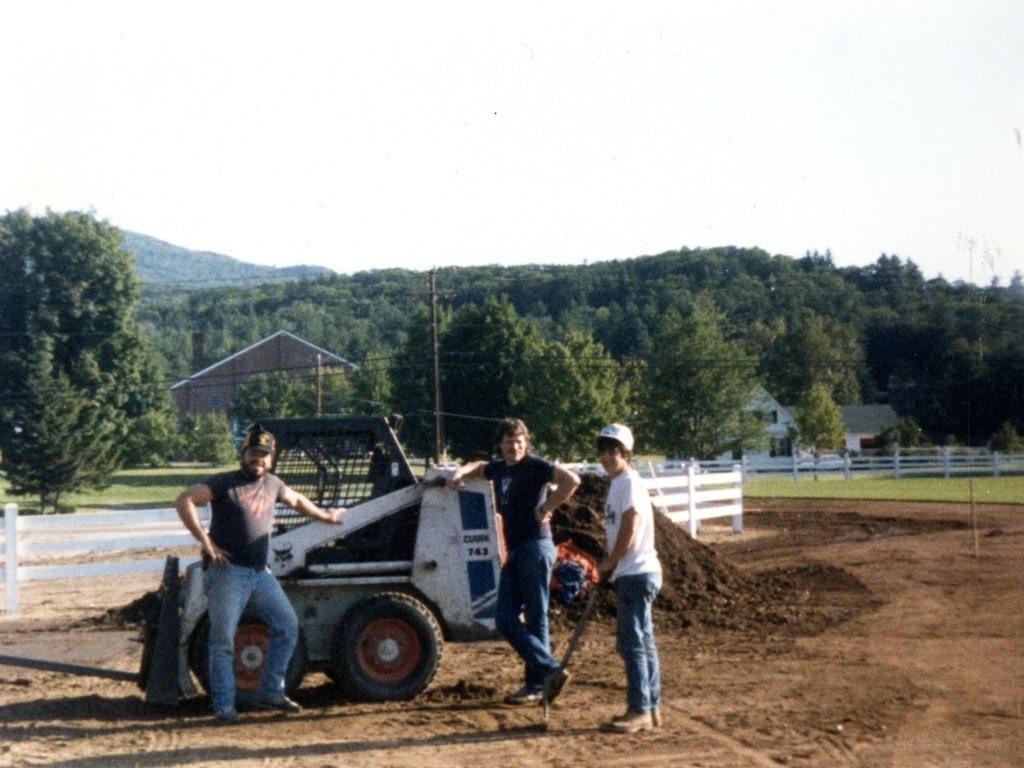What can you infer about the location and time of year this photo was taken? The presence of lush green trees and the attire of the individuals, wearing short sleeves and hats, suggest it is a warm season, likely spring or summer. The mountain range in the background, coupled with the rural setting and the fence running parallel to the road, depicts a country-like environment, possibly in regions like the Appalachians or the Rockies if we consider the U.S. The long shadows cast could imply that the photo was taken in the early morning or late afternoon. 